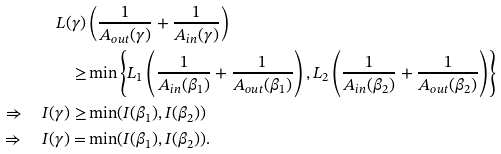Convert formula to latex. <formula><loc_0><loc_0><loc_500><loc_500>L ( \gamma ) & \left ( \frac { 1 } { A _ { o u t } ( \gamma ) } + \frac { 1 } { A _ { i n } ( \gamma ) } \right ) \\ \geq & \min \left \{ L _ { 1 } \left ( \frac { 1 } { A _ { i n } ( \beta _ { 1 } ) } + \frac { 1 } { A _ { o u t } ( \beta _ { 1 } ) } \right ) , L _ { 2 } \left ( \frac { 1 } { A _ { i n } ( \beta _ { 2 } ) } + \frac { 1 } { A _ { o u t } ( \beta _ { 2 } ) } \right ) \right \} \\ \Rightarrow \quad I ( \gamma ) \geq & \min ( I ( \beta _ { 1 } ) , I ( \beta _ { 2 } ) ) \\ \Rightarrow \quad I ( \gamma ) = & \min ( I ( \beta _ { 1 } ) , I ( \beta _ { 2 } ) ) .</formula> 